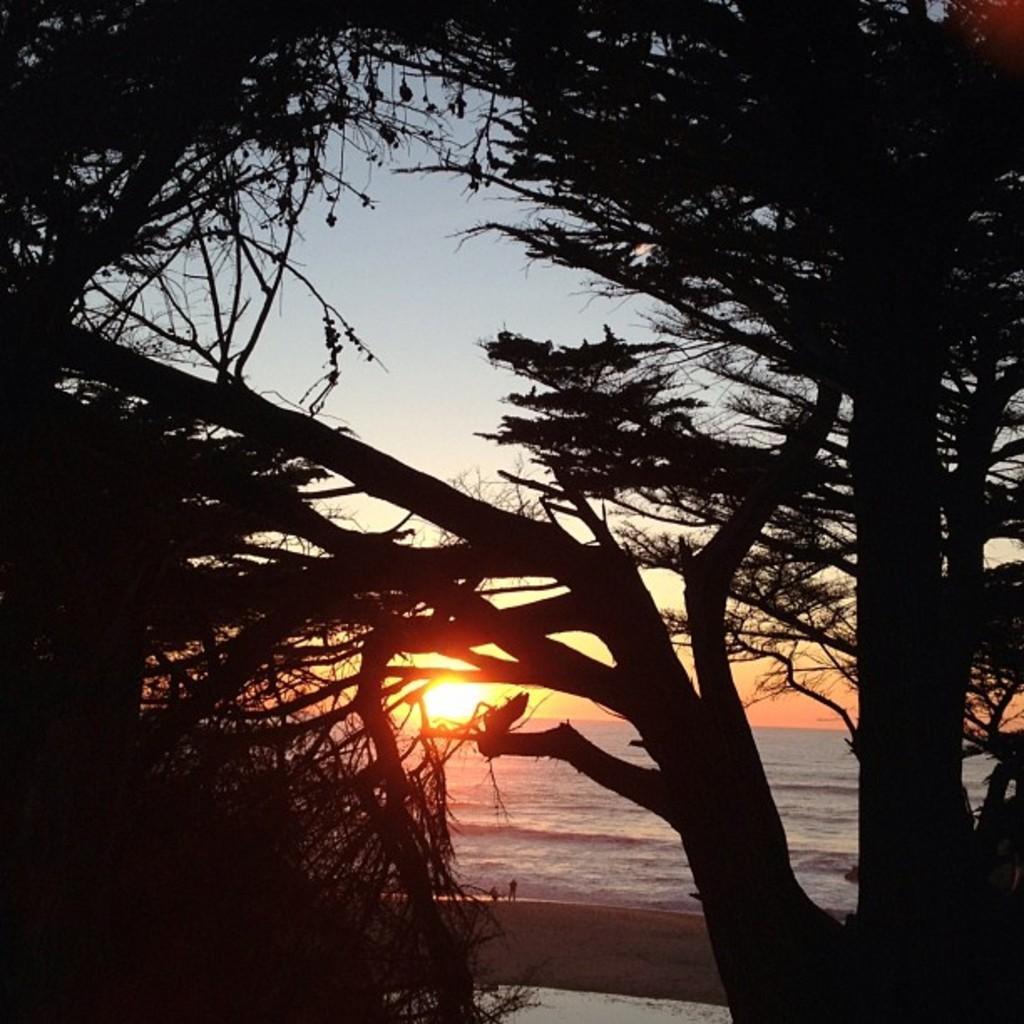Could you give a brief overview of what you see in this image? In the foreground I can see the trees. It seems like a beach. In the background, I can see the water and there are two persons standing and also I can see the sun in the sky. 